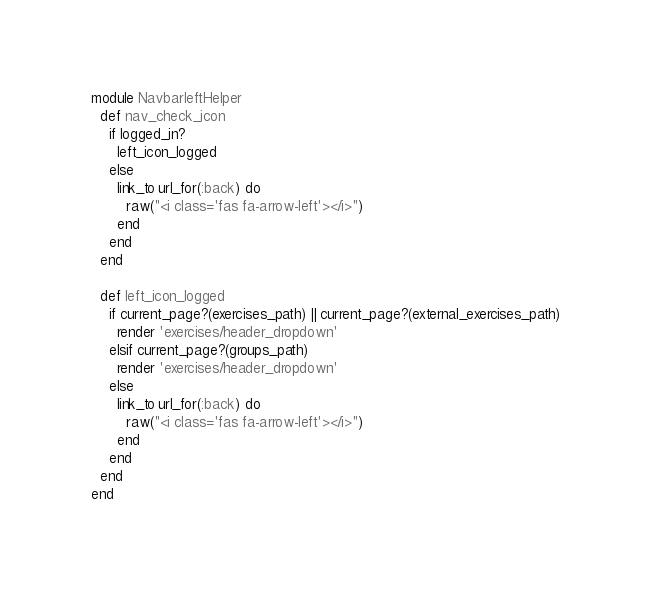Convert code to text. <code><loc_0><loc_0><loc_500><loc_500><_Ruby_>module NavbarleftHelper
  def nav_check_icon
    if logged_in?
      left_icon_logged
    else
      link_to url_for(:back) do
        raw("<i class='fas fa-arrow-left'></i>")
      end
    end
  end

  def left_icon_logged
    if current_page?(exercises_path) || current_page?(external_exercises_path)
      render 'exercises/header_dropdown'
    elsif current_page?(groups_path)
      render 'exercises/header_dropdown'
    else
      link_to url_for(:back) do
        raw("<i class='fas fa-arrow-left'></i>")
      end
    end
  end
end
</code> 